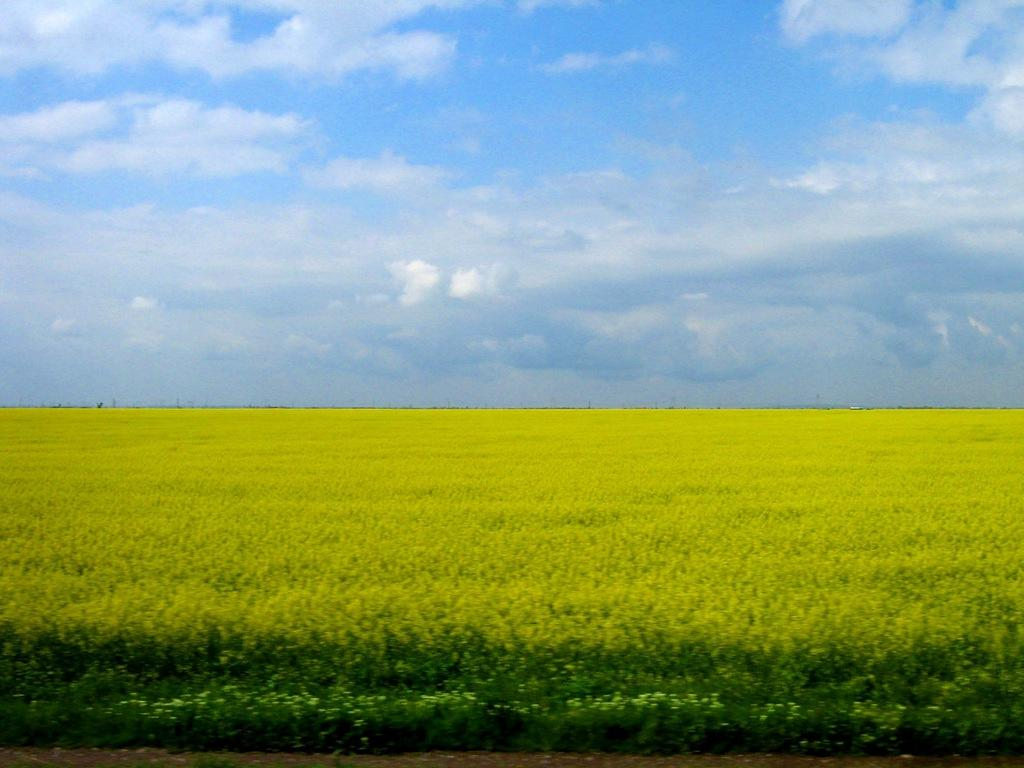What is located at the bottom of the image? There is a field at the bottom of the image. What is visible at the top of the image? The sky is visible at the top of the image. What can be seen in the sky? Clouds are present in the sky. Where is the throne located in the image? There is no throne present in the image. What type of body is visible in the image? There is no body present in the image; it features a field and clouds in the sky. 